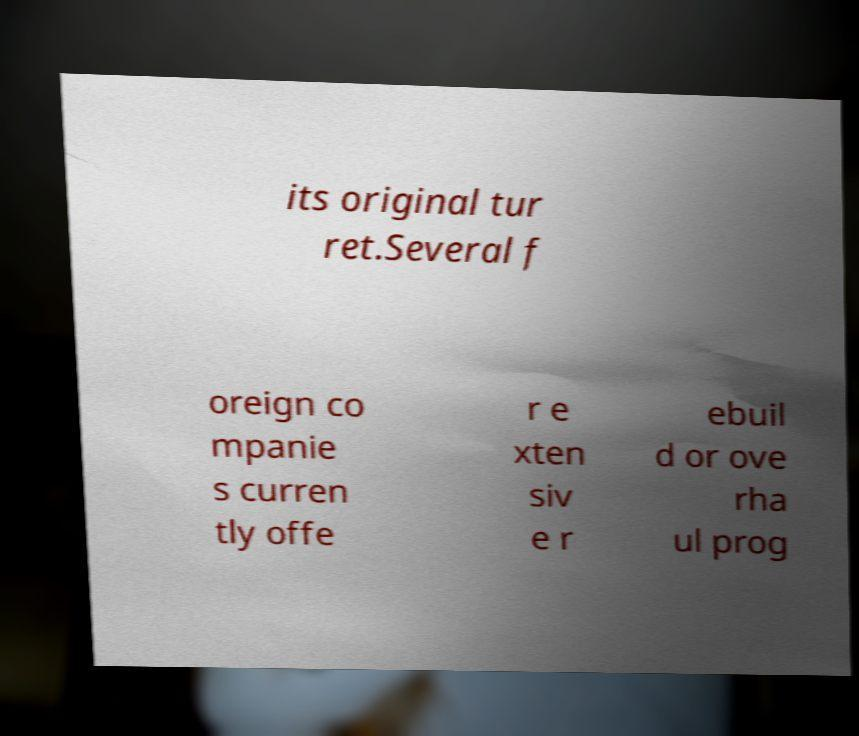Could you assist in decoding the text presented in this image and type it out clearly? its original tur ret.Several f oreign co mpanie s curren tly offe r e xten siv e r ebuil d or ove rha ul prog 